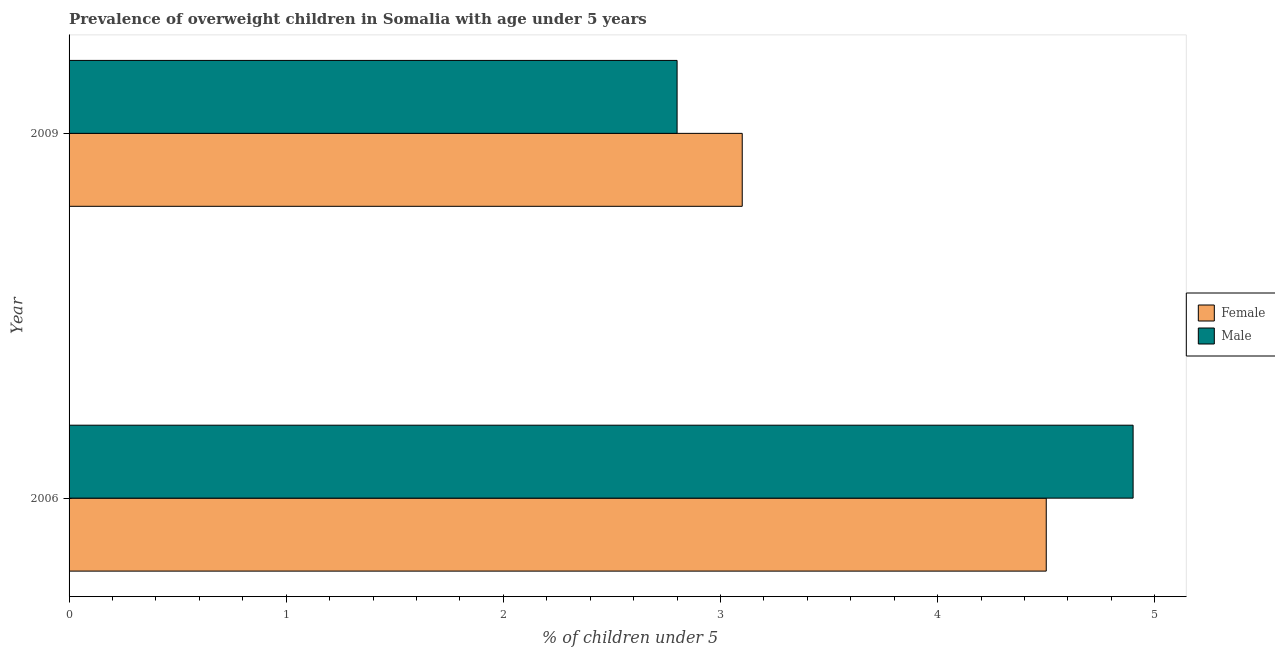What is the label of the 2nd group of bars from the top?
Give a very brief answer. 2006. In how many cases, is the number of bars for a given year not equal to the number of legend labels?
Your answer should be very brief. 0. What is the percentage of obese male children in 2009?
Your answer should be very brief. 2.8. Across all years, what is the minimum percentage of obese male children?
Provide a succinct answer. 2.8. What is the total percentage of obese female children in the graph?
Ensure brevity in your answer.  7.6. What is the difference between the percentage of obese male children in 2006 and that in 2009?
Keep it short and to the point. 2.1. What is the difference between the percentage of obese female children in 2009 and the percentage of obese male children in 2006?
Offer a terse response. -1.8. What is the average percentage of obese male children per year?
Keep it short and to the point. 3.85. Is the percentage of obese female children in 2006 less than that in 2009?
Give a very brief answer. No. What does the 1st bar from the top in 2009 represents?
Give a very brief answer. Male. How many bars are there?
Your response must be concise. 4. Are the values on the major ticks of X-axis written in scientific E-notation?
Your answer should be very brief. No. Does the graph contain grids?
Keep it short and to the point. No. Where does the legend appear in the graph?
Make the answer very short. Center right. What is the title of the graph?
Provide a succinct answer. Prevalence of overweight children in Somalia with age under 5 years. What is the label or title of the X-axis?
Offer a terse response.  % of children under 5. What is the  % of children under 5 of Male in 2006?
Make the answer very short. 4.9. What is the  % of children under 5 of Female in 2009?
Offer a terse response. 3.1. What is the  % of children under 5 of Male in 2009?
Offer a very short reply. 2.8. Across all years, what is the maximum  % of children under 5 in Female?
Make the answer very short. 4.5. Across all years, what is the maximum  % of children under 5 of Male?
Provide a succinct answer. 4.9. Across all years, what is the minimum  % of children under 5 of Female?
Your response must be concise. 3.1. Across all years, what is the minimum  % of children under 5 in Male?
Your answer should be compact. 2.8. What is the total  % of children under 5 in Female in the graph?
Your response must be concise. 7.6. What is the total  % of children under 5 in Male in the graph?
Keep it short and to the point. 7.7. What is the difference between the  % of children under 5 in Male in 2006 and that in 2009?
Provide a short and direct response. 2.1. What is the difference between the  % of children under 5 of Female in 2006 and the  % of children under 5 of Male in 2009?
Make the answer very short. 1.7. What is the average  % of children under 5 of Female per year?
Keep it short and to the point. 3.8. What is the average  % of children under 5 of Male per year?
Provide a short and direct response. 3.85. In the year 2006, what is the difference between the  % of children under 5 of Female and  % of children under 5 of Male?
Provide a succinct answer. -0.4. What is the ratio of the  % of children under 5 of Female in 2006 to that in 2009?
Your answer should be very brief. 1.45. What is the difference between the highest and the second highest  % of children under 5 in Female?
Your response must be concise. 1.4. What is the difference between the highest and the second highest  % of children under 5 of Male?
Give a very brief answer. 2.1. What is the difference between the highest and the lowest  % of children under 5 in Male?
Provide a succinct answer. 2.1. 